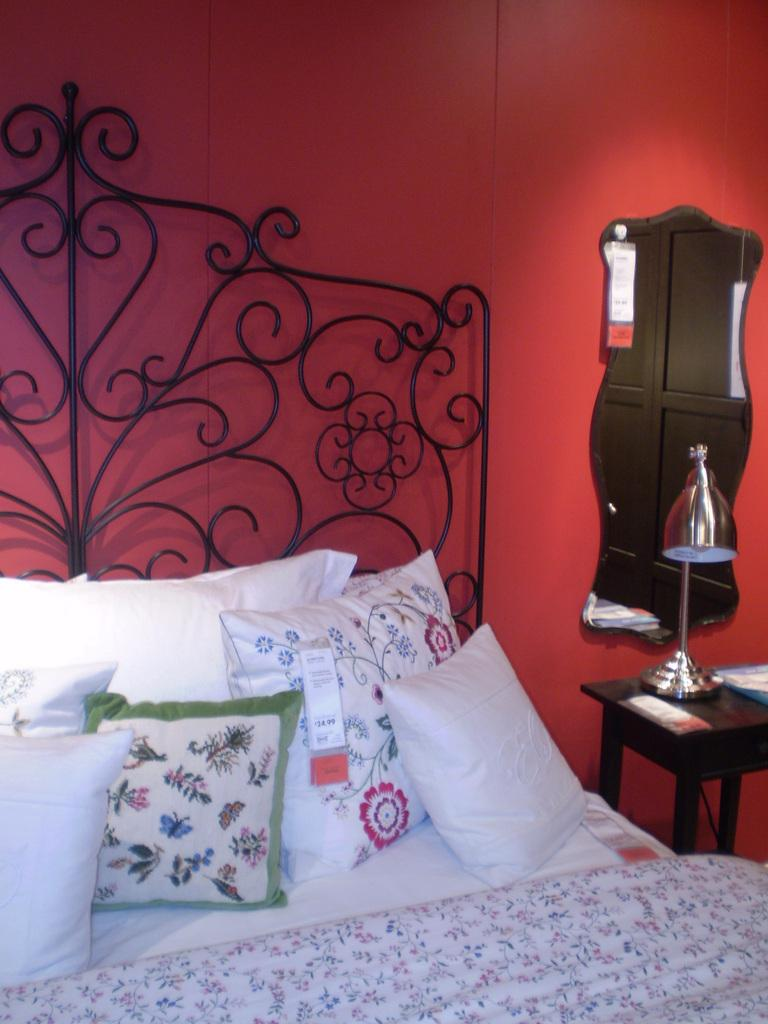What piece of furniture is present in the image? There is a bed in the image. What is placed on the bed? The bed has pillows on it. What reflective object is visible in the image? There is a mirror in the image. What is placed on the mirror? There is a lamp on the mirror. What time of day is it in the image, and is there a fireman present? The time of day cannot be determined from the image, and there is no fireman present. Can you see a drain in the image? There is no drain visible in the image. 